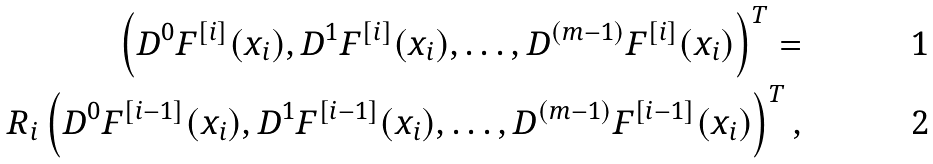<formula> <loc_0><loc_0><loc_500><loc_500>\left ( D ^ { 0 } F ^ { [ i ] } ( x _ { i } ) , D ^ { 1 } F ^ { [ i ] } ( x _ { i } ) , \dots , D ^ { ( m - 1 ) } F ^ { [ i ] } ( x _ { i } ) \right ) ^ { T } = \\ R _ { i } \left ( D ^ { 0 } F ^ { [ i - 1 ] } ( x _ { i } ) , D ^ { 1 } F ^ { [ i - 1 ] } ( x _ { i } ) , \dots , D ^ { ( m - 1 ) } F ^ { [ i - 1 ] } ( x _ { i } ) \right ) ^ { T } ,</formula> 